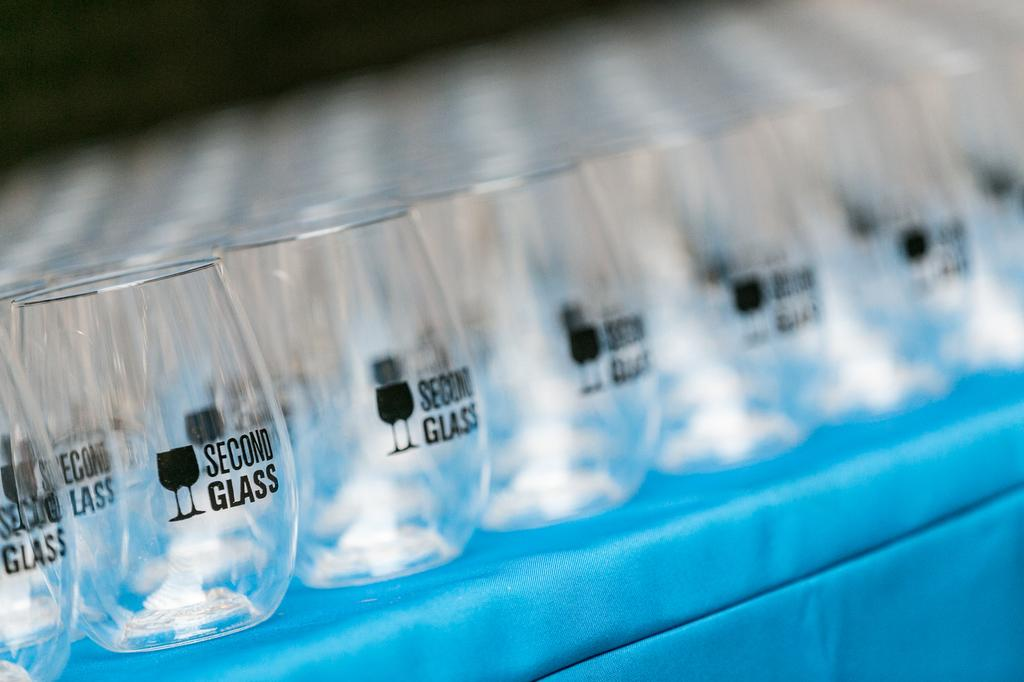What objects are present in the image? There are glasses in the picture. What is the color of the surface on which the glasses are placed? The glasses are kept on a blue surface. How many glasses are the main focus in the image? Only a few glasses are highlighted in the image. What type of quill is being used to support the glasses in the image? There is no quill present in the image, and the glasses are not being supported by any object. 